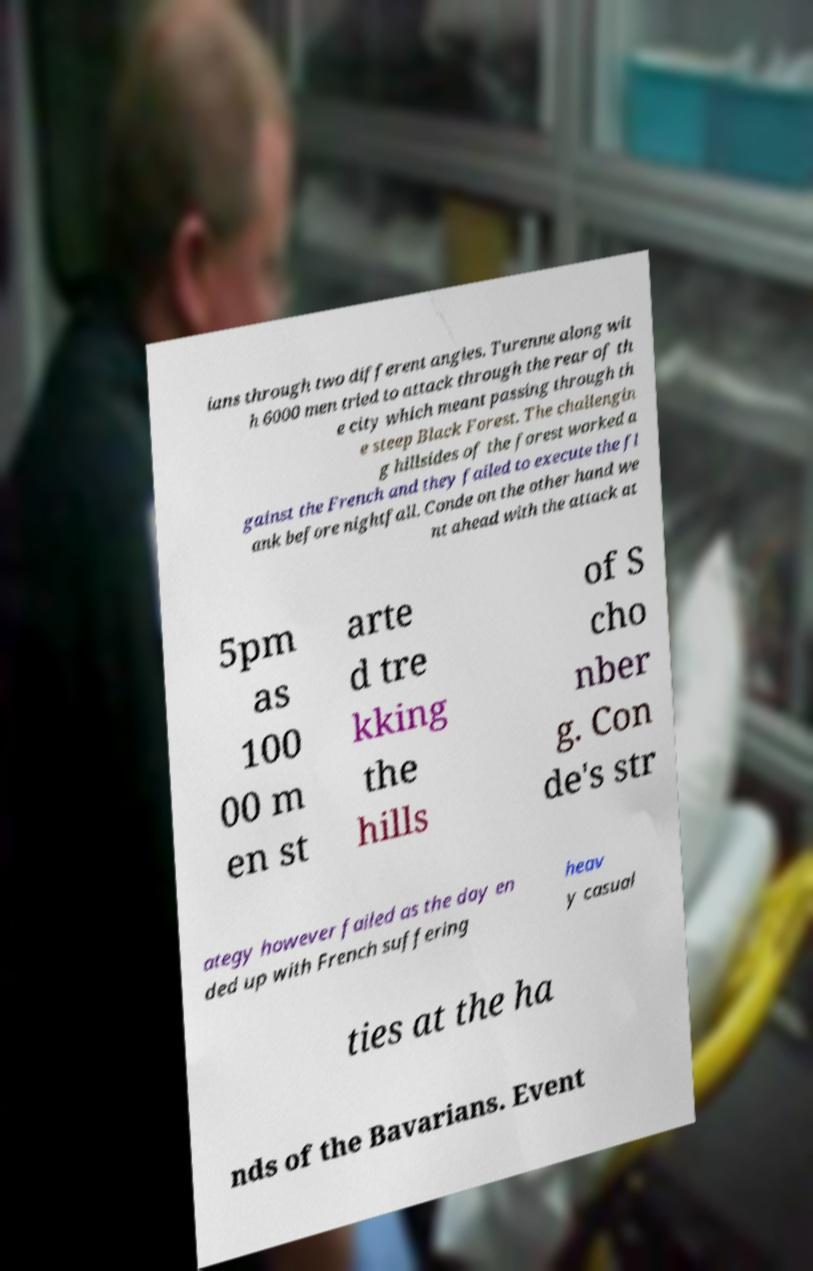What messages or text are displayed in this image? I need them in a readable, typed format. ians through two different angles. Turenne along wit h 6000 men tried to attack through the rear of th e city which meant passing through th e steep Black Forest. The challengin g hillsides of the forest worked a gainst the French and they failed to execute the fl ank before nightfall. Conde on the other hand we nt ahead with the attack at 5pm as 100 00 m en st arte d tre kking the hills of S cho nber g. Con de's str ategy however failed as the day en ded up with French suffering heav y casual ties at the ha nds of the Bavarians. Event 